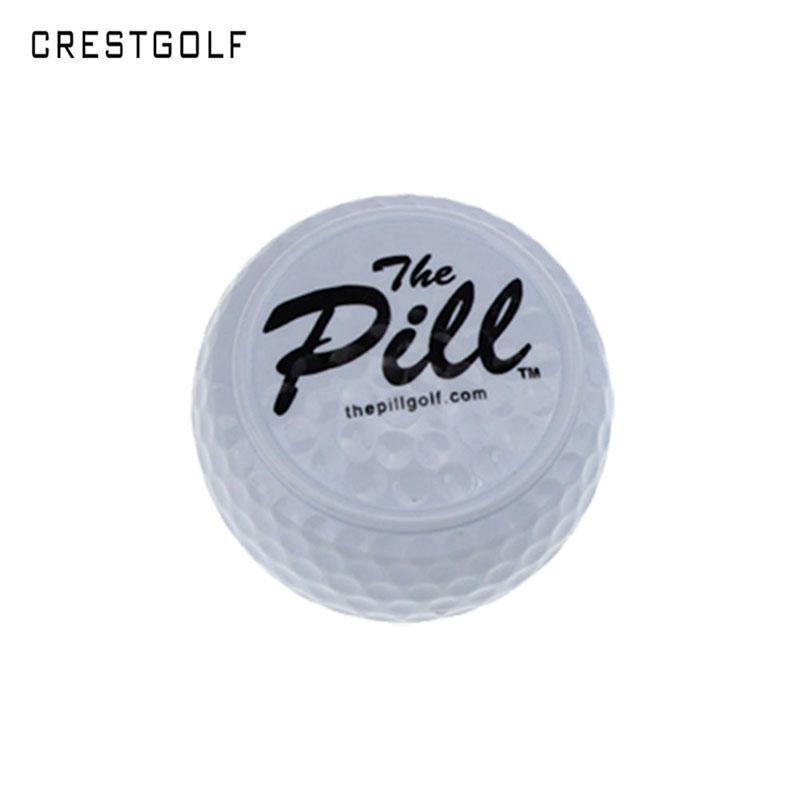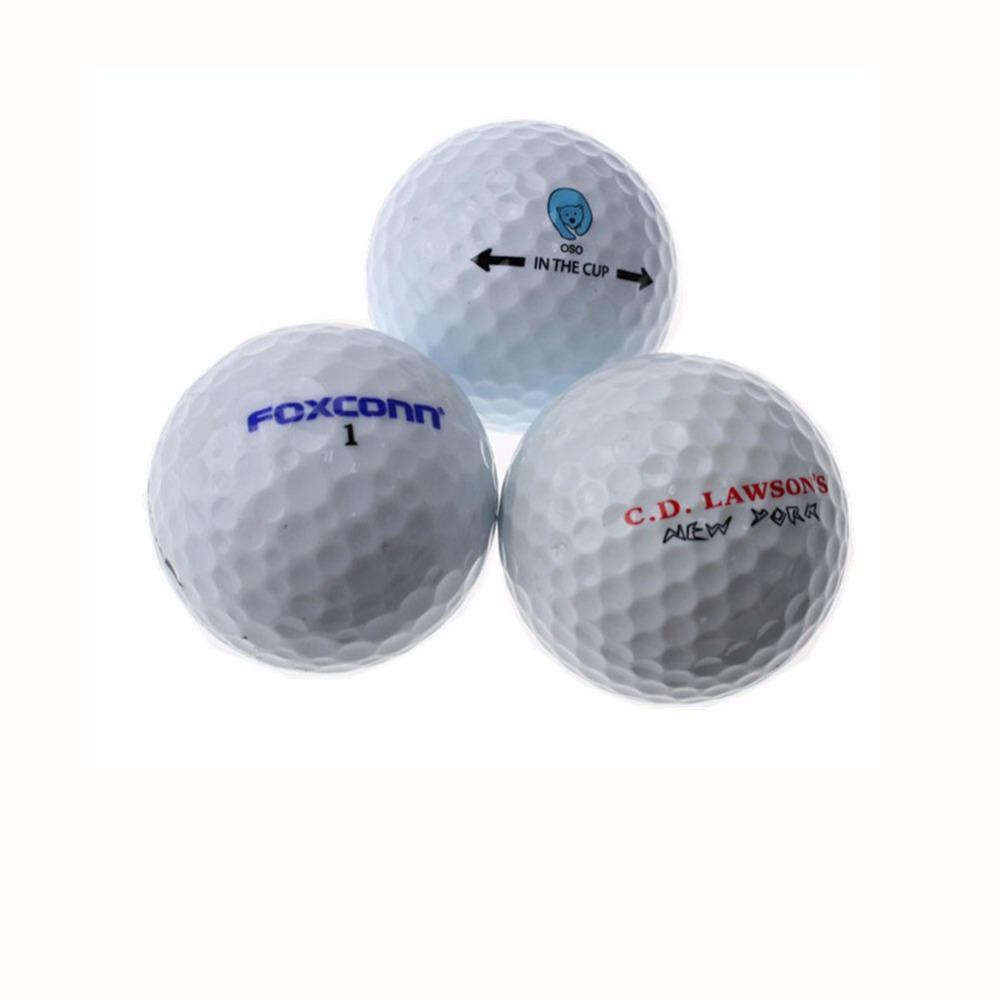The first image is the image on the left, the second image is the image on the right. For the images displayed, is the sentence "The right image contains exactly three golf balls in a triangular formation." factually correct? Answer yes or no. Yes. The first image is the image on the left, the second image is the image on the right. For the images shown, is this caption "One image shows a pyramid shape formed by three golf balls, and the other image contains no more than one golf ball." true? Answer yes or no. Yes. 